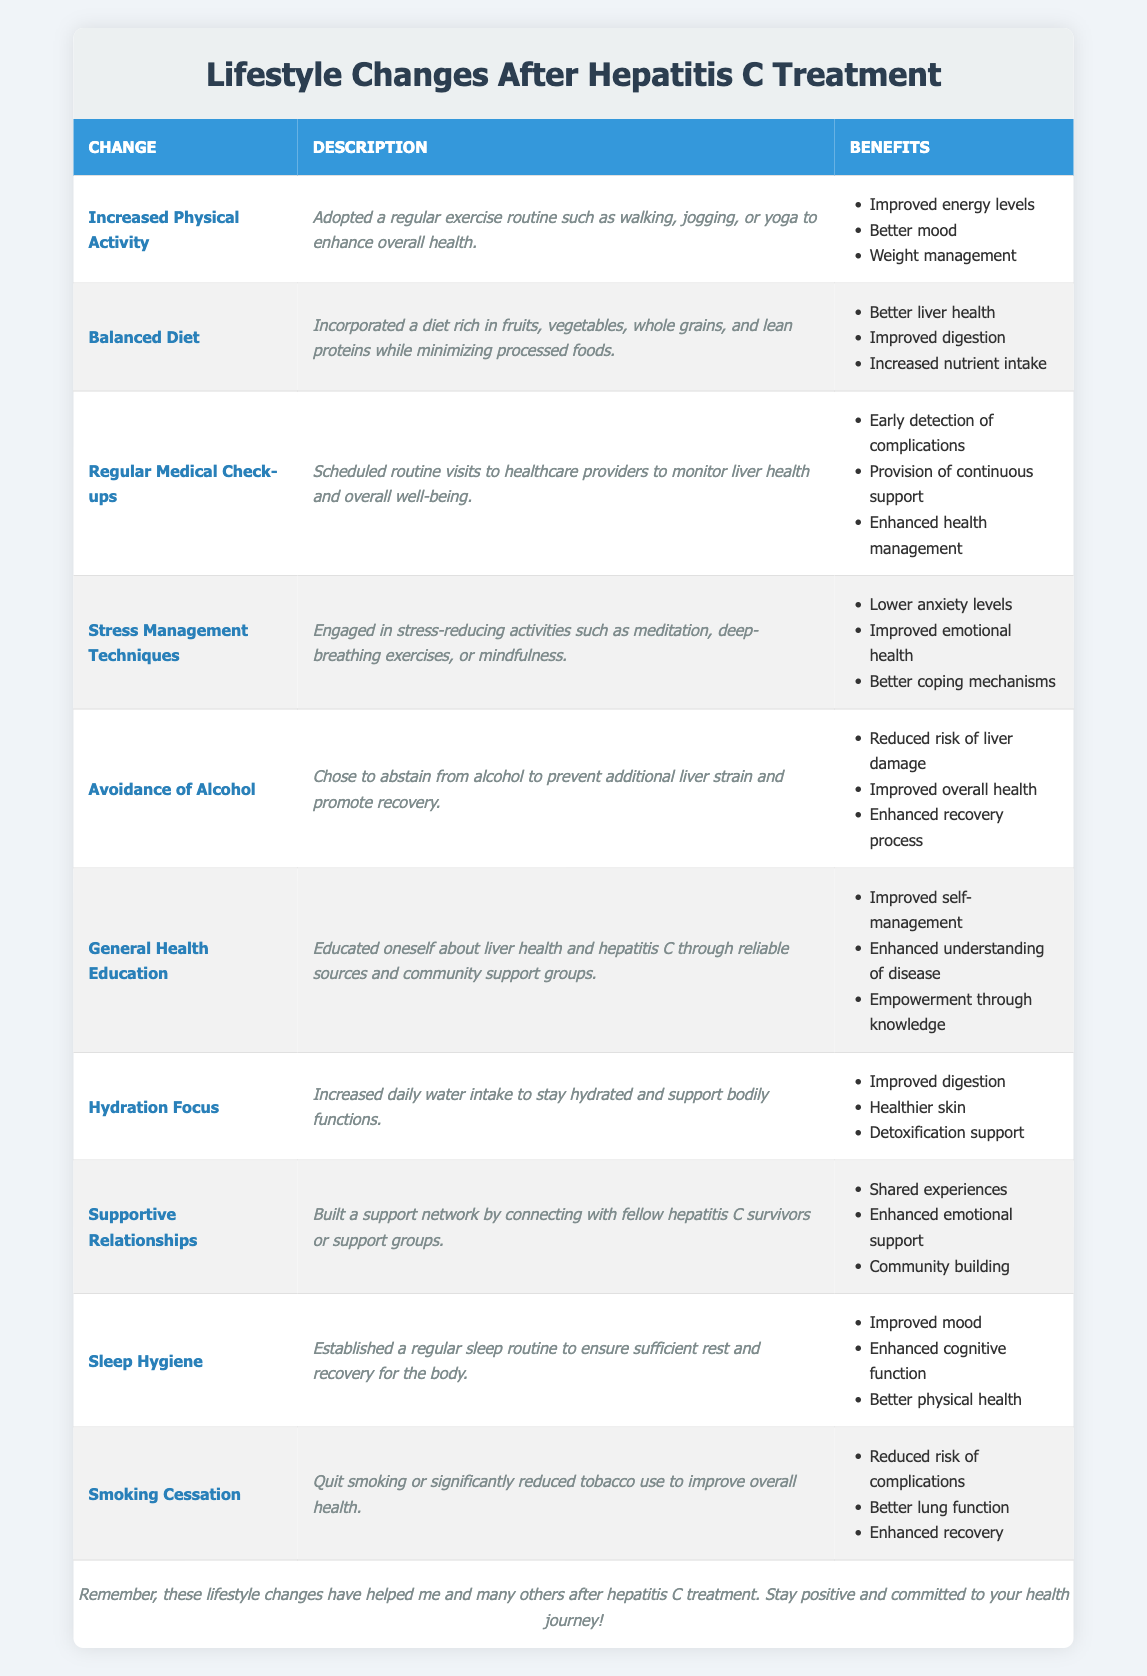What is one lifestyle change that helps improve liver health? By reviewing the table, "Balanced Diet" is listed as a lifestyle change. Its description indicates it incorporates a diet rich in fruits, vegetables, whole grains, and lean proteins while minimizing processed foods. This change directly supports better liver health.
Answer: Balanced Diet How many benefits are listed for stress management techniques? In the table, "Stress Management Techniques" has three benefits listed: lower anxiety levels, improved emotional health, and better coping mechanisms. Therefore, the total number of benefits is three.
Answer: 3 Does the "Avoidance of Alcohol" help in enhancing the recovery process? According to the table, one of the benefits under "Avoidance of Alcohol" is "Enhanced recovery process," indicating that this lifestyle change does indeed support recovery.
Answer: Yes Which lifestyle change offers the benefit of shared experiences? The lifestyle change called "Supportive Relationships" specifically mentions the benefit of "Shared experiences" among its listed benefits, confirming it is aimed at building a network of support.
Answer: Supportive Relationships What are the benefits of adopting a regular exercise routine? The table shows that "Increased Physical Activity" has three benefits: improved energy levels, better mood, and weight management. Summarizing, these improvements enhance overall health and well-being.
Answer: Improved energy levels, better mood, weight management Which two lifestyle changes focus on mental and emotional well-being? Reviewing the table, "Stress Management Techniques" promotes emotional health through various activities, while "Supportive Relationships" fosters community and shared experiences. Both changes intricately contribute to improved mental and emotional well-being.
Answer: Stress Management Techniques, Supportive Relationships What is the average number of benefits listed per lifestyle change? There are 10 lifestyle changes in the table, and their total benefits count is 25. To find the average, we divide 25 by 10, resulting in an average of 2.5 benefits per lifestyle change.
Answer: 2.5 Is it true that all lifestyle changes improve overall health? By analyzing the benefits listed for each lifestyle change, it is clear that many changes like "Increased Physical Activity," "Balanced Diet," and "Avoidance of Alcohol" explicitly mention improving overall health or associated benefits, confirming this fact is true for most.
Answer: Yes How many changes directly relate to hydration and sleep? The table includes "Hydration Focus" for hydration and "Sleep Hygiene" for sleep, totaling two distinct lifestyle changes directly related to these aspects of health.
Answer: 2 